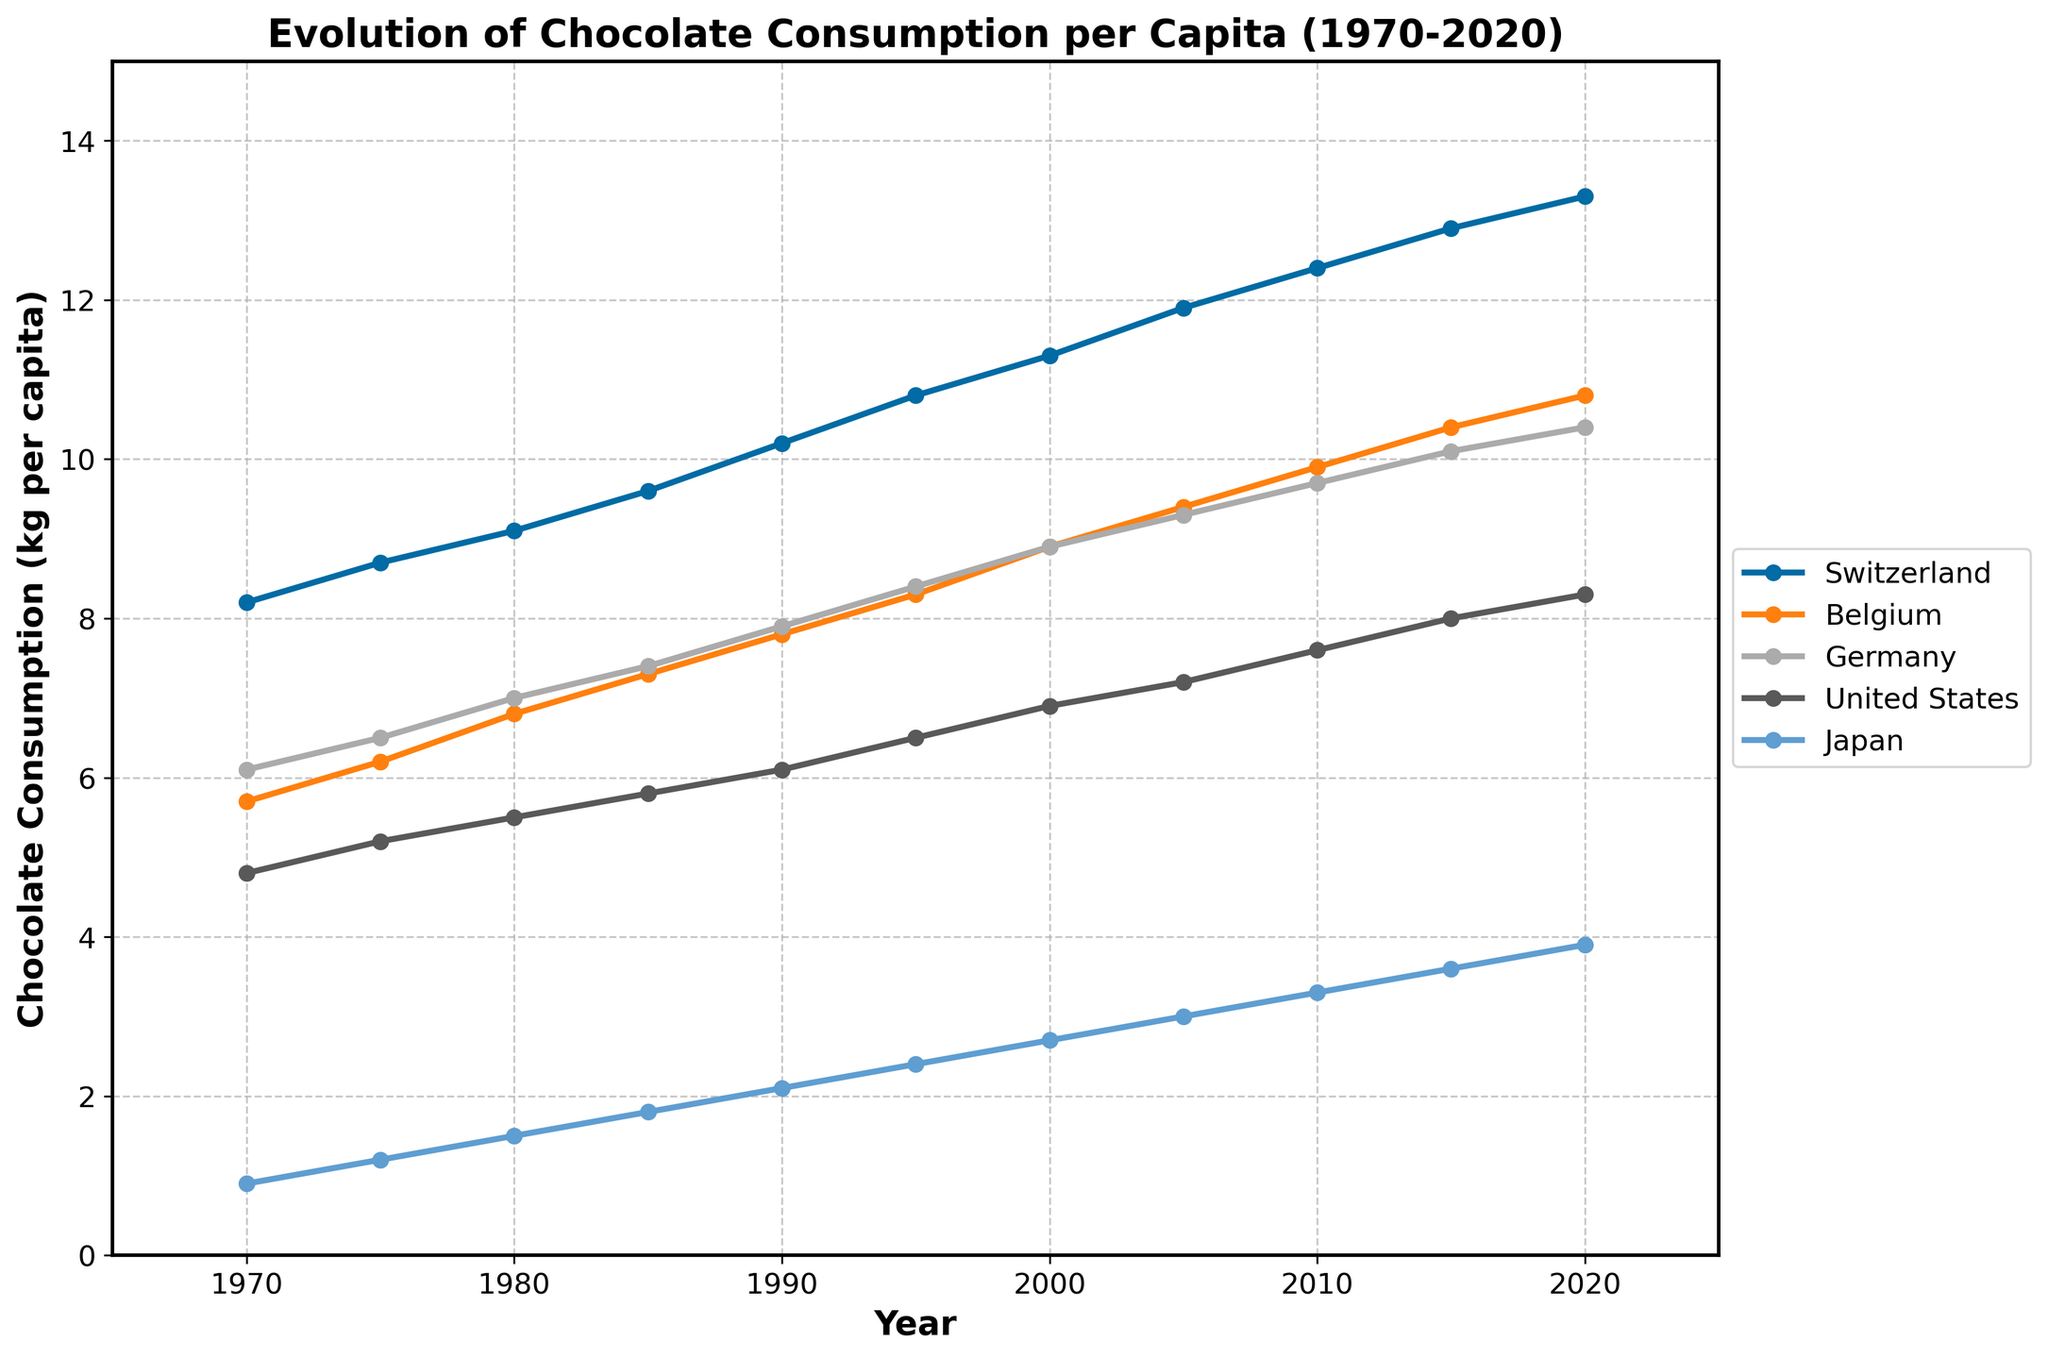What is the average chocolate consumption in Switzerland from 1970 to 2020? To find the average, sum the values for Switzerland from 1970 to 2020 and then divide by the number of years. The values are 8.2, 8.7, 9.1, 9.6, 10.2, 10.8, 11.3, 11.9, 12.4, 12.9, 13.3. Sum these values to get 118.4 and then divide by 11 (number of years) to get the average.
Answer: 10.8 Which country had the highest chocolate consumption in 2020? Look at the endpoints of each line in the year 2020 and compare the values. Switzerland's line ends at 13.3 kg per capita, which is higher than the others.
Answer: Switzerland How did chocolate consumption in Japan change from 1970 to 2020? To determine the change, subtract the 1970 value from the 2020 value for Japan. The values are 3.9 (2020) and 0.9 (1970), so the change is 3.9 - 0.9 = 3.0 kg per capita increase.
Answer: Increased by 3.0 kg per capita Between Belgium and Germany, which country saw a larger increase in chocolate consumption from 1970 to 2020? Calculate the increase for both countries by subtracting the 1970 value from the 2020 value. For Belgium, it is 10.8 - 5.7 = 5.1, and for Germany, it is 10.4 - 6.1 = 4.3. Belgium has a larger increase.
Answer: Belgium In what year did chocolate consumption in the United States first exceed 6 kg per capita? Locate the year at which the line for the United States crosses the 6 kg per capita mark. This happens between 1990 and 1995. Checking the data, it exceeds 6 in 1995.
Answer: 1995 By how much did chocolate consumption in Germany increase between 1990 and 2000? To find the increase, subtract the value in 1990 from the value in 2000 for Germany. The values are 8.9 (2000) and 7.9 (1990), so the increase is 8.9 - 7.9 = 1.0 kg per capita.
Answer: 1.0 kg per capita Which country had the lowest chocolate consumption in 1985? Compare the values at the year 1985 for all countries. Japan has the lowest value of 1.8 kg per capita.
Answer: Japan Did chocolate consumption in Belgium ever surpass that in Switzerland? Visually compare the lines of Belgium and Switzerland throughout the timeline. The line for Belgium never surpasses the line for Switzerland at any point.
Answer: No What was the rate of increase in chocolate consumption in Switzerland from 2000 to 2020 in kg per capita per year? To find the rate, divide the increase over the period by the number of years. From 2000 to 2020, the increase for Switzerland is 13.3 - 11.3 = 2.0, over 20 years. The rate is 2.0 / 20 = 0.1 kg per capita per year.
Answer: 0.1 kg per capita per year 